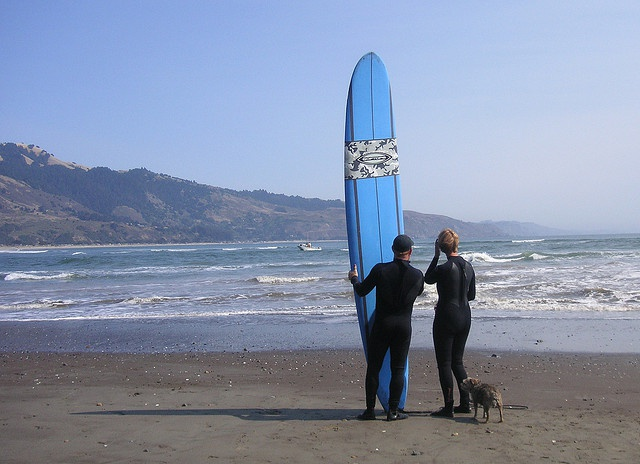Describe the objects in this image and their specific colors. I can see surfboard in gray, lightblue, blue, navy, and black tones, people in gray, black, navy, and darkblue tones, people in gray, black, and darkgray tones, dog in gray and black tones, and boat in gray, white, and darkgray tones in this image. 